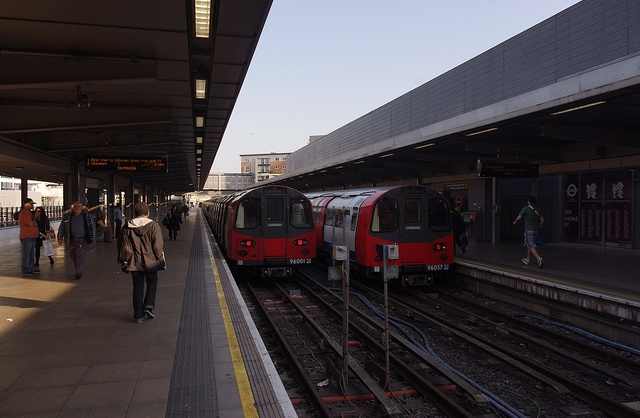Describe the objects in this image and their specific colors. I can see train in black, maroon, gray, and darkgray tones, train in black, maroon, and gray tones, people in black, brown, and maroon tones, people in black, maroon, and gray tones, and people in black, maroon, and brown tones in this image. 